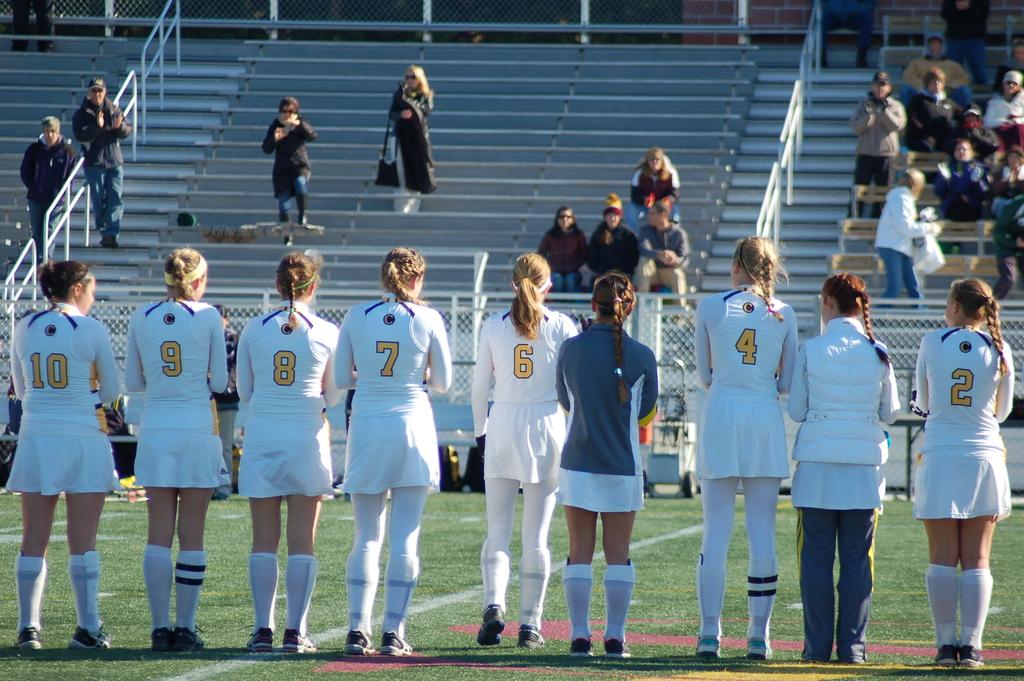What is the right-most player's jersey number?
Offer a terse response. 2. 